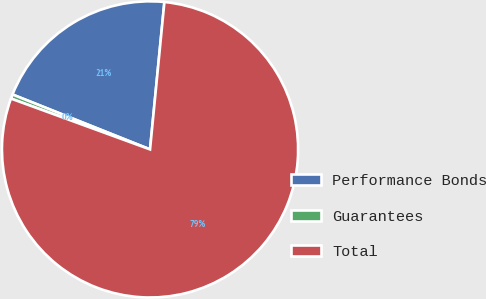<chart> <loc_0><loc_0><loc_500><loc_500><pie_chart><fcel>Performance Bonds<fcel>Guarantees<fcel>Total<nl><fcel>20.5%<fcel>0.47%<fcel>79.02%<nl></chart> 